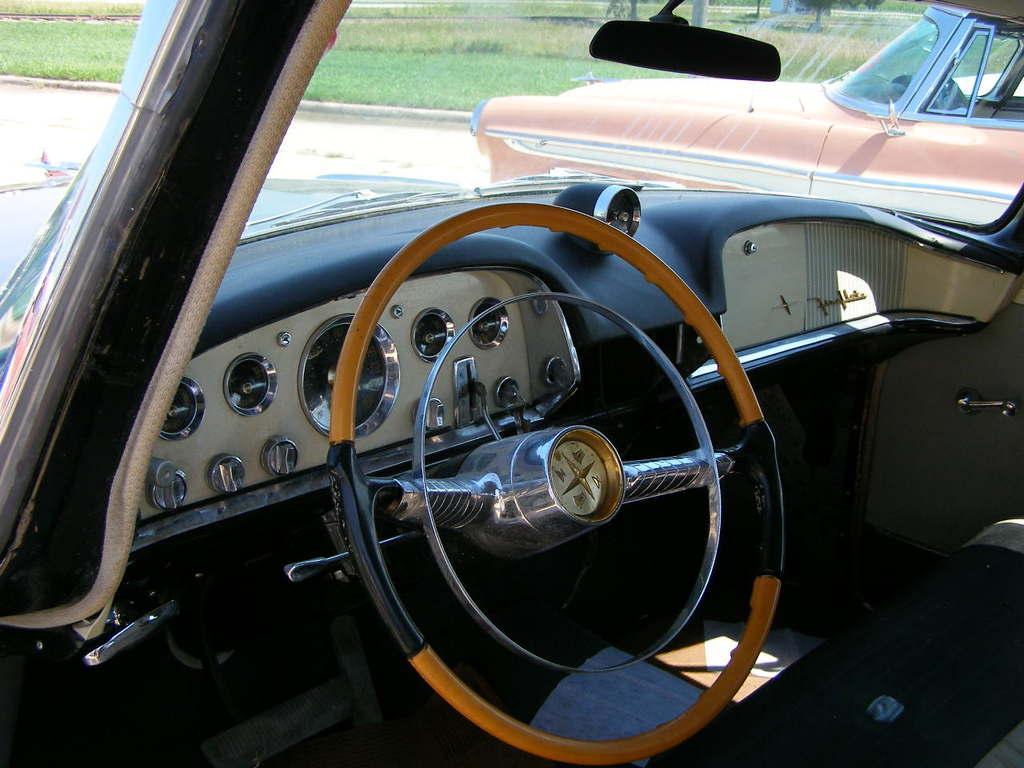In one or two sentences, can you explain what this image depicts? In this image we can see the inside view of the car. And we can see the Speedometer, Steering wheel, mirror and glass. And beside we can see other vehicles. And we can see the grass. 